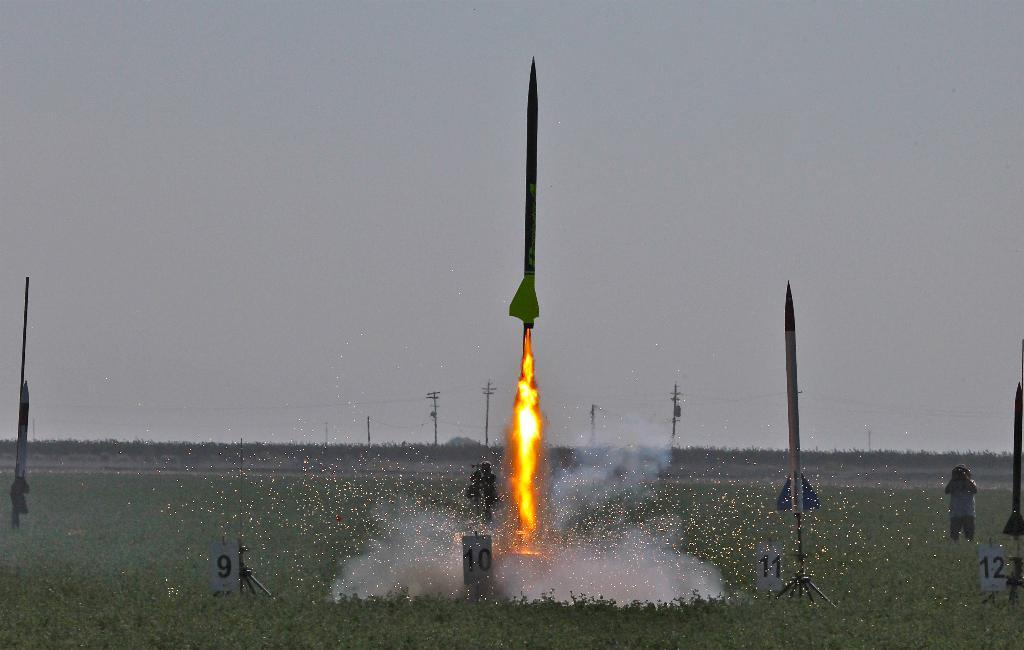What is the main subject of the image? The main subject of the image is rockets. What can be seen in the image besides the rockets? There is fire, smoke, boards, a person standing, poles, trees, and the sky visible in the image. Can you describe the person in the image? There is a person standing in the image. What is visible in the background of the image? The background of the image includes poles, trees, and the sky. What type of animal can be seen interacting with the rockets in the image? There are no animals present in the image, and therefore no such interaction can be observed. Can you tell me the credit score of the person standing in the image? There is no information about the person's credit score in the image. 